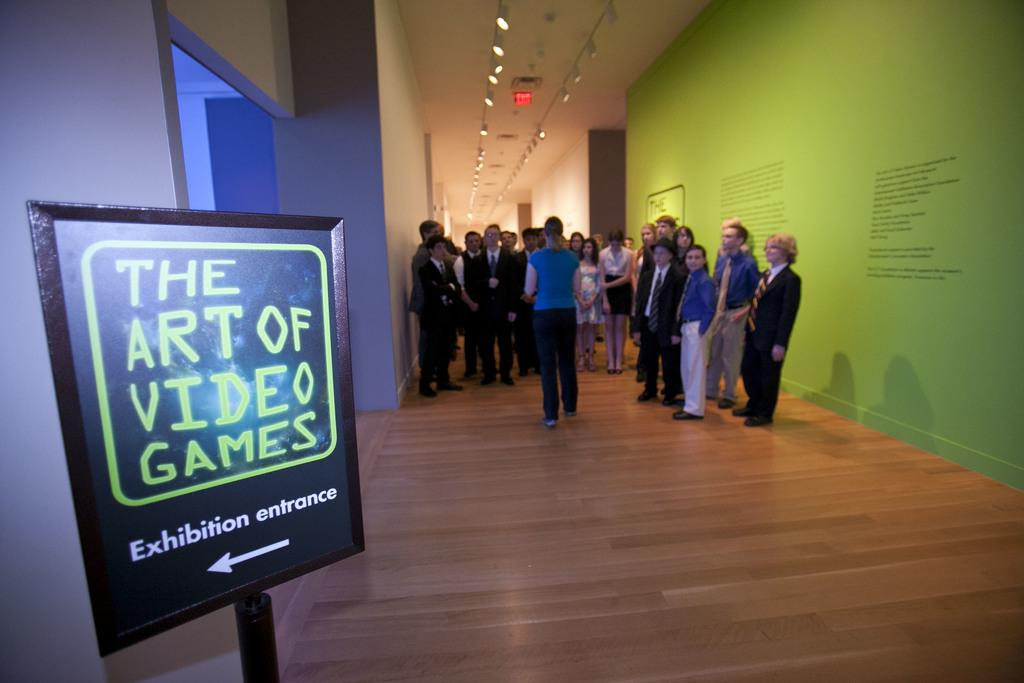<image>
Write a terse but informative summary of the picture. A group of people waits in the hall down from the Art of Video Games exhibition entrance. 